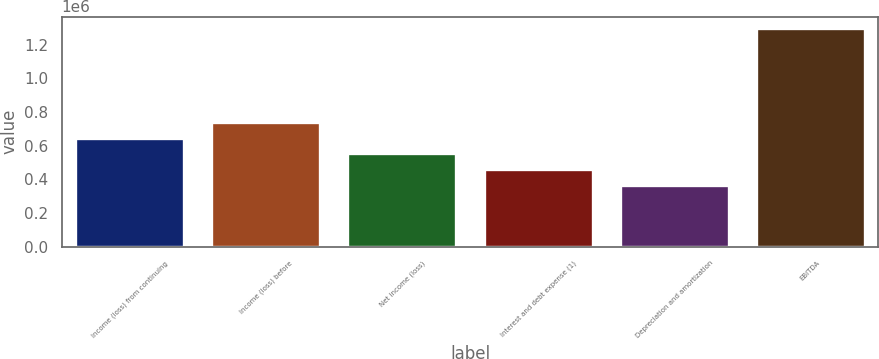Convert chart to OTSL. <chart><loc_0><loc_0><loc_500><loc_500><bar_chart><fcel>Income (loss) from continuing<fcel>Income (loss) before<fcel>Net income (loss)<fcel>Interest and debt expense (1)<fcel>Depreciation and amortization<fcel>EBITDA<nl><fcel>647570<fcel>741007<fcel>554134<fcel>460697<fcel>367260<fcel>1.30163e+06<nl></chart> 